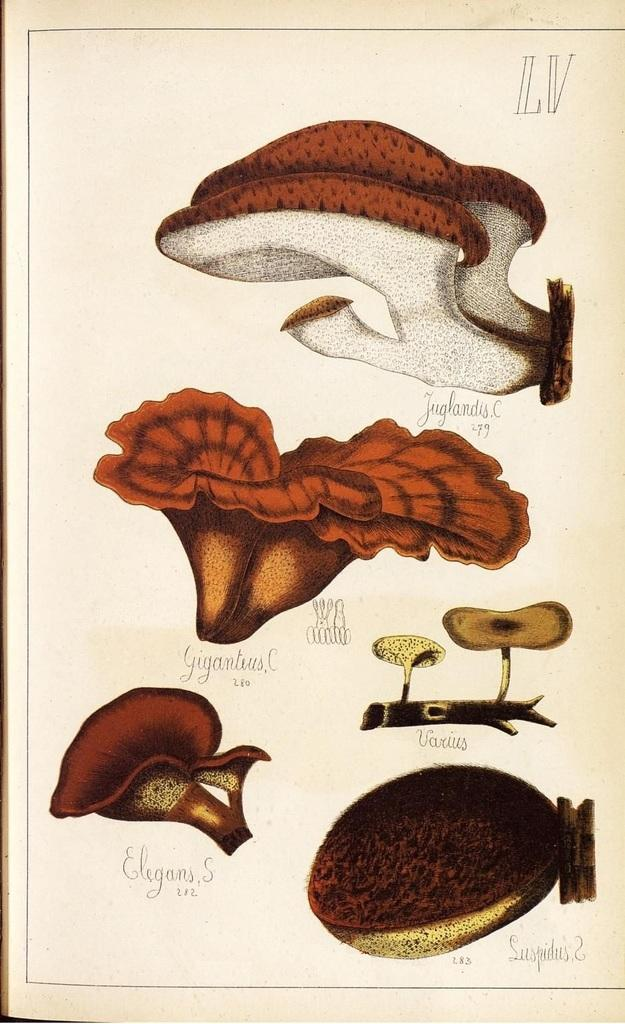What is the main subject of the paper in the image? The paper contains pictures of plants. Are there any other elements on the paper besides the pictures? Yes, there is text on the paper. What type of power source is depicted in the image? There is no power source depicted in the image; it features a paper with pictures of plants and text. How many cows are visible in the image? There are no cows present in the image. 